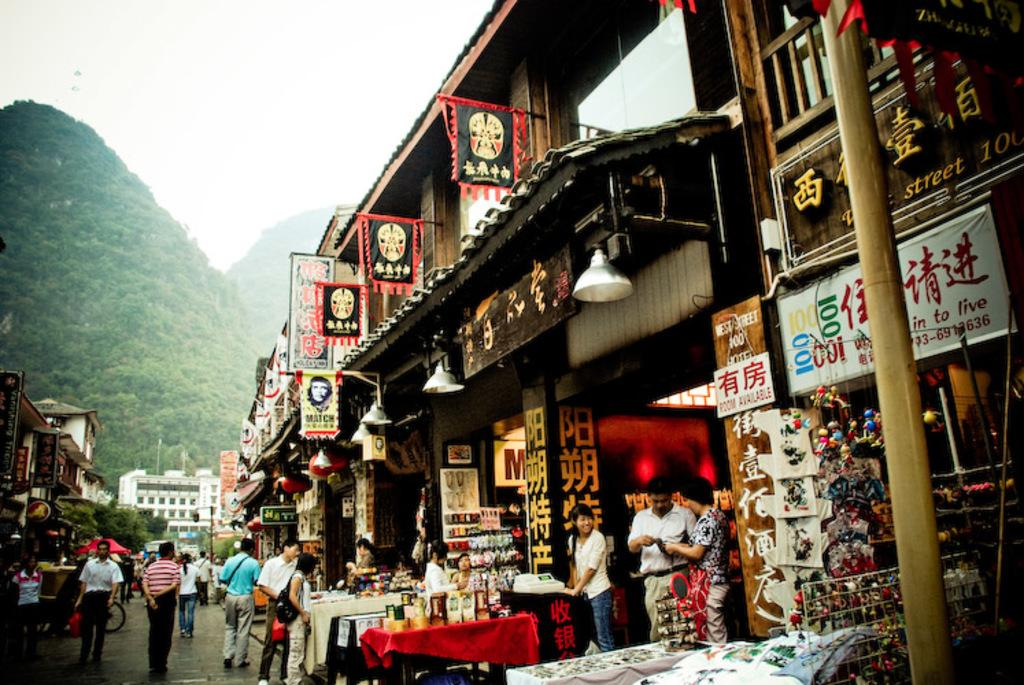<image>
Create a compact narrative representing the image presented. A busy foreign street with a brown sign that reads West Street 100. 